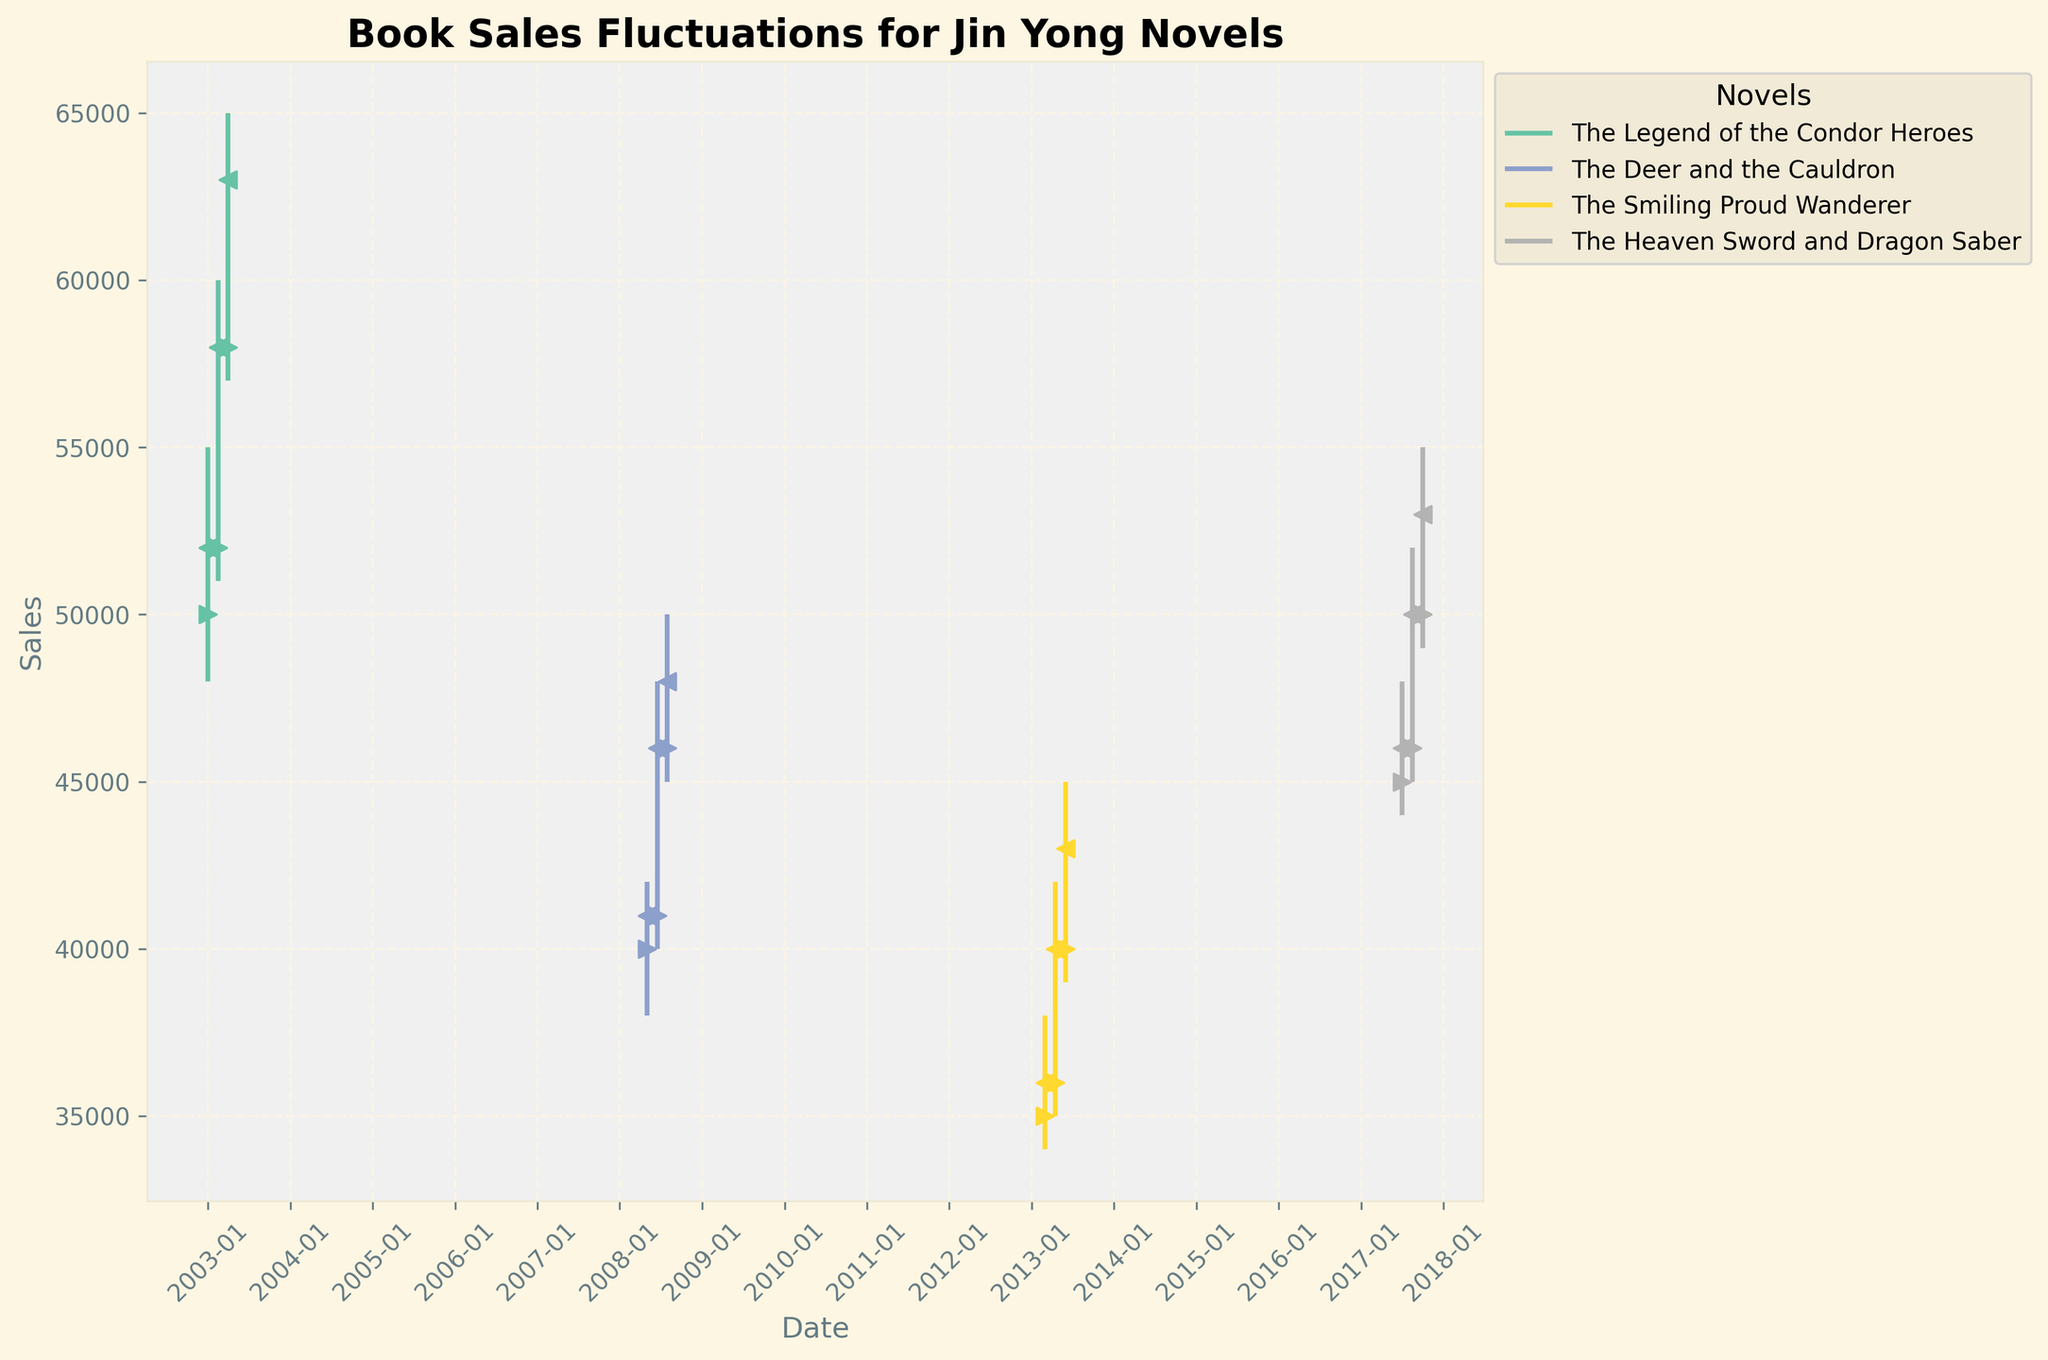What's the title of the figure? The title of the figure is usually found at the top of the chart. By looking at the figure, you can see the larger text centered at the top, which gives a brief description of what the figure represents. Here, it says "Book Sales Fluctuations for Jin Yong Novels".
Answer: Book Sales Fluctuations for Jin Yong Novels How many novels are represented in the figure? Each novel is represented by a unique color and labeled in the legend. By counting the different entries in the legend, we can determine the number of novels. There are four entries in the legend, each corresponding to a different novel.
Answer: Four novels Which novel had the highest sales peak, and what was the value? To find the novel with the highest sales peak, look at the vertical lines that represent the high values on the OHLC chart. The highest point is marked, and the label in the legend will tell us which novel it corresponds to. The highest peak is for "The Legend of the Condor Heroes" at 65000.
Answer: The Legend of the Condor Heroes; 65000 What is the average of the closing prices for "The Deer and the Cauldron"? We need to find the closing prices for "The Deer and the Cauldron" from the chart and calculate their average. The closing prices are 41000, 46000, and 48000. Sum them up (41000 + 46000 + 48000 = 135000) and divide by the number of points (3), the average is 135000/3.
Answer: 45000 Which novel demonstrated the highest increase in sales just after its adaptation release? Compare the difference between the opening and closing prices over consecutive periods for each novel by checking the vertical lines and scatter markers. "The Legend of the Condor Heroes" from 52000 to 63000 shows the highest single period increase of 11000 units (63000 - 52000 = 11000).
Answer: The Legend of the Condor Heroes How did the sales trend for "The Smiling Proud Wanderer" change over the three recorded periods? Inspect the OHLC chart for "The Smiling Proud Wanderer" and check the "Close" prices visually. The closing prices are 36000, 40000, and 43000 respectively, showing an increasing trend over the three periods.
Answer: Increasing trend What was the lowest sales figure recorded for "The Heaven Sword and Dragon Saber"? Locate the lowest points on the vertical lines for "The Heaven Sword and Dragon Saber" by looking at the minimum value. The lowest sales figure recorded is 44000.
Answer: 44000 Among all the novels, which one had the smallest range between its high and low values during any period? Identify the ranges by calculating the difference between each high and low for all periods and novels on the chart. The smallest range observed is for "The Smiling Proud Wanderer" in the period with a range of (38000 - 34000 = 4000).
Answer: The Smiling Proud Wanderer What patterns can you observe regarding sales fluctuations around adaptation release dates? Review the trends in the OHLC chart around key dates indicating adaptation releases. Both "The Legend of the Condor Heroes" and "The Deer and the Cauldron" show significant increases after release dates, indicating a positive impact on sales.
Answer: Increased sales after adaptations 